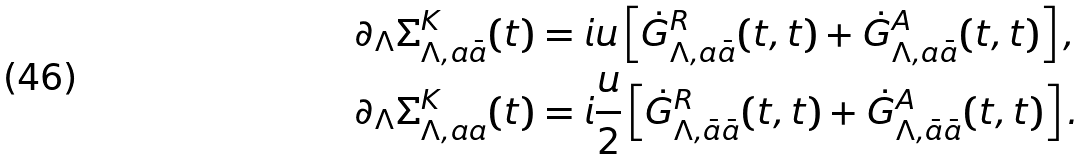<formula> <loc_0><loc_0><loc_500><loc_500>\partial _ { \Lambda } \Sigma ^ { K } _ { \Lambda , a \bar { a } } ( t ) & = i u \left [ \dot { G } ^ { R } _ { \Lambda , a \bar { a } } ( t , t ) + \dot { G } ^ { A } _ { \Lambda , a \bar { a } } ( t , t ) \right ] , \\ \partial _ { \Lambda } \Sigma ^ { K } _ { \Lambda , a { a } } ( t ) & = i \frac { u } { 2 } \left [ \dot { G } ^ { R } _ { \Lambda , \bar { a } \bar { a } } ( t , t ) + \dot { G } ^ { A } _ { \Lambda , \bar { a } \bar { a } } ( t , t ) \right ] .</formula> 